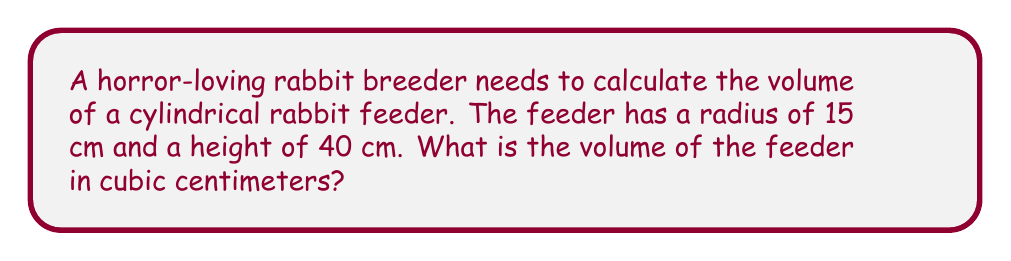Solve this math problem. To find the volume of a cylindrical rabbit feeder, we need to use the formula for the volume of a cylinder:

$$V = \pi r^2 h$$

Where:
$V$ = volume
$r$ = radius of the base
$h$ = height of the cylinder

Given:
$r = 15$ cm
$h = 40$ cm

Let's substitute these values into the formula:

$$V = \pi (15\text{ cm})^2 (40\text{ cm})$$

Simplify:
$$V = \pi (225\text{ cm}^2) (40\text{ cm})$$
$$V = 9000\pi\text{ cm}^3$$

Calculate the final value (rounded to the nearest whole number):
$$V \approx 28,274\text{ cm}^3$$

[asy]
import geometry;

size(200);
real r = 1.5;
real h = 4;

path base = circle((0,0), r);
path top = circle((0,h), r);

draw(base);
draw(top);
draw((r,0)--(r,h));
draw((-r,0)--(-r,h));

label("r", (r/2,0), E);
label("h", (r,h/2), E);

draw((0,0)--(r,0), Arrow);
draw((r,0)--(r,h), Arrow);
[/asy]
Answer: $28,274\text{ cm}^3$ 